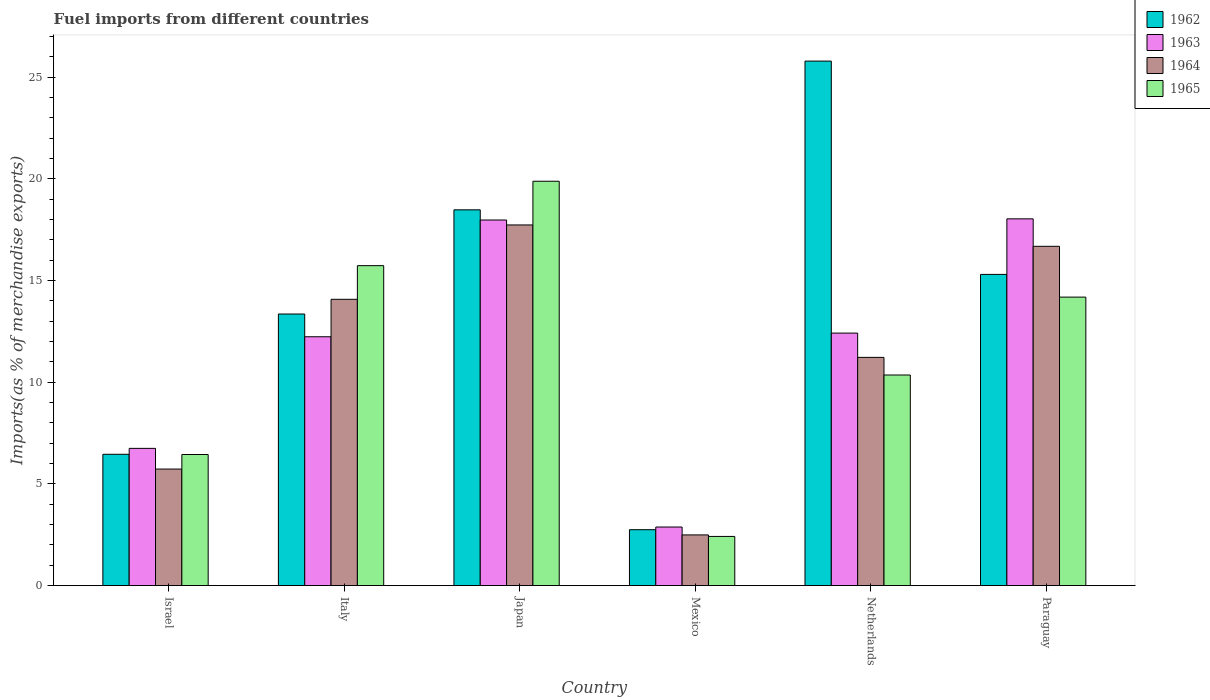Are the number of bars per tick equal to the number of legend labels?
Your answer should be very brief. Yes. Are the number of bars on each tick of the X-axis equal?
Keep it short and to the point. Yes. How many bars are there on the 2nd tick from the left?
Ensure brevity in your answer.  4. What is the label of the 5th group of bars from the left?
Your answer should be very brief. Netherlands. What is the percentage of imports to different countries in 1965 in Israel?
Provide a succinct answer. 6.44. Across all countries, what is the maximum percentage of imports to different countries in 1965?
Give a very brief answer. 19.88. Across all countries, what is the minimum percentage of imports to different countries in 1965?
Offer a very short reply. 2.42. What is the total percentage of imports to different countries in 1965 in the graph?
Your answer should be very brief. 69. What is the difference between the percentage of imports to different countries in 1962 in Israel and that in Japan?
Keep it short and to the point. -12.02. What is the difference between the percentage of imports to different countries in 1965 in Japan and the percentage of imports to different countries in 1964 in Mexico?
Ensure brevity in your answer.  17.39. What is the average percentage of imports to different countries in 1962 per country?
Give a very brief answer. 13.69. What is the difference between the percentage of imports to different countries of/in 1962 and percentage of imports to different countries of/in 1964 in Israel?
Keep it short and to the point. 0.73. In how many countries, is the percentage of imports to different countries in 1962 greater than 18 %?
Provide a short and direct response. 2. What is the ratio of the percentage of imports to different countries in 1964 in Italy to that in Netherlands?
Provide a short and direct response. 1.25. What is the difference between the highest and the second highest percentage of imports to different countries in 1965?
Your response must be concise. 5.7. What is the difference between the highest and the lowest percentage of imports to different countries in 1963?
Offer a very short reply. 15.15. In how many countries, is the percentage of imports to different countries in 1962 greater than the average percentage of imports to different countries in 1962 taken over all countries?
Keep it short and to the point. 3. Is it the case that in every country, the sum of the percentage of imports to different countries in 1963 and percentage of imports to different countries in 1964 is greater than the sum of percentage of imports to different countries in 1965 and percentage of imports to different countries in 1962?
Give a very brief answer. No. What does the 2nd bar from the left in Mexico represents?
Provide a succinct answer. 1963. What does the 2nd bar from the right in Japan represents?
Keep it short and to the point. 1964. Is it the case that in every country, the sum of the percentage of imports to different countries in 1963 and percentage of imports to different countries in 1965 is greater than the percentage of imports to different countries in 1964?
Your answer should be very brief. Yes. How many bars are there?
Your answer should be very brief. 24. How many countries are there in the graph?
Ensure brevity in your answer.  6. Does the graph contain any zero values?
Your answer should be compact. No. Does the graph contain grids?
Provide a succinct answer. No. Where does the legend appear in the graph?
Your answer should be compact. Top right. How are the legend labels stacked?
Provide a succinct answer. Vertical. What is the title of the graph?
Make the answer very short. Fuel imports from different countries. Does "1999" appear as one of the legend labels in the graph?
Give a very brief answer. No. What is the label or title of the X-axis?
Your answer should be compact. Country. What is the label or title of the Y-axis?
Offer a very short reply. Imports(as % of merchandise exports). What is the Imports(as % of merchandise exports) in 1962 in Israel?
Offer a terse response. 6.45. What is the Imports(as % of merchandise exports) in 1963 in Israel?
Your response must be concise. 6.75. What is the Imports(as % of merchandise exports) of 1964 in Israel?
Give a very brief answer. 5.73. What is the Imports(as % of merchandise exports) of 1965 in Israel?
Give a very brief answer. 6.44. What is the Imports(as % of merchandise exports) in 1962 in Italy?
Your answer should be very brief. 13.35. What is the Imports(as % of merchandise exports) in 1963 in Italy?
Your answer should be very brief. 12.23. What is the Imports(as % of merchandise exports) of 1964 in Italy?
Your answer should be very brief. 14.07. What is the Imports(as % of merchandise exports) in 1965 in Italy?
Make the answer very short. 15.73. What is the Imports(as % of merchandise exports) in 1962 in Japan?
Your answer should be very brief. 18.47. What is the Imports(as % of merchandise exports) of 1963 in Japan?
Provide a short and direct response. 17.97. What is the Imports(as % of merchandise exports) in 1964 in Japan?
Ensure brevity in your answer.  17.73. What is the Imports(as % of merchandise exports) of 1965 in Japan?
Offer a terse response. 19.88. What is the Imports(as % of merchandise exports) of 1962 in Mexico?
Make the answer very short. 2.75. What is the Imports(as % of merchandise exports) in 1963 in Mexico?
Provide a short and direct response. 2.88. What is the Imports(as % of merchandise exports) of 1964 in Mexico?
Make the answer very short. 2.49. What is the Imports(as % of merchandise exports) of 1965 in Mexico?
Ensure brevity in your answer.  2.42. What is the Imports(as % of merchandise exports) in 1962 in Netherlands?
Offer a very short reply. 25.79. What is the Imports(as % of merchandise exports) in 1963 in Netherlands?
Keep it short and to the point. 12.41. What is the Imports(as % of merchandise exports) of 1964 in Netherlands?
Offer a terse response. 11.22. What is the Imports(as % of merchandise exports) in 1965 in Netherlands?
Make the answer very short. 10.35. What is the Imports(as % of merchandise exports) of 1962 in Paraguay?
Provide a short and direct response. 15.3. What is the Imports(as % of merchandise exports) of 1963 in Paraguay?
Offer a terse response. 18.03. What is the Imports(as % of merchandise exports) of 1964 in Paraguay?
Keep it short and to the point. 16.68. What is the Imports(as % of merchandise exports) in 1965 in Paraguay?
Provide a short and direct response. 14.18. Across all countries, what is the maximum Imports(as % of merchandise exports) in 1962?
Ensure brevity in your answer.  25.79. Across all countries, what is the maximum Imports(as % of merchandise exports) in 1963?
Keep it short and to the point. 18.03. Across all countries, what is the maximum Imports(as % of merchandise exports) in 1964?
Provide a succinct answer. 17.73. Across all countries, what is the maximum Imports(as % of merchandise exports) in 1965?
Make the answer very short. 19.88. Across all countries, what is the minimum Imports(as % of merchandise exports) in 1962?
Offer a very short reply. 2.75. Across all countries, what is the minimum Imports(as % of merchandise exports) of 1963?
Provide a succinct answer. 2.88. Across all countries, what is the minimum Imports(as % of merchandise exports) in 1964?
Provide a succinct answer. 2.49. Across all countries, what is the minimum Imports(as % of merchandise exports) in 1965?
Your response must be concise. 2.42. What is the total Imports(as % of merchandise exports) in 1962 in the graph?
Your answer should be compact. 82.11. What is the total Imports(as % of merchandise exports) in 1963 in the graph?
Your response must be concise. 70.28. What is the total Imports(as % of merchandise exports) of 1964 in the graph?
Give a very brief answer. 67.93. What is the total Imports(as % of merchandise exports) of 1965 in the graph?
Offer a terse response. 69. What is the difference between the Imports(as % of merchandise exports) in 1962 in Israel and that in Italy?
Offer a terse response. -6.9. What is the difference between the Imports(as % of merchandise exports) of 1963 in Israel and that in Italy?
Provide a short and direct response. -5.49. What is the difference between the Imports(as % of merchandise exports) of 1964 in Israel and that in Italy?
Offer a very short reply. -8.35. What is the difference between the Imports(as % of merchandise exports) of 1965 in Israel and that in Italy?
Your answer should be very brief. -9.29. What is the difference between the Imports(as % of merchandise exports) of 1962 in Israel and that in Japan?
Make the answer very short. -12.02. What is the difference between the Imports(as % of merchandise exports) of 1963 in Israel and that in Japan?
Ensure brevity in your answer.  -11.23. What is the difference between the Imports(as % of merchandise exports) of 1964 in Israel and that in Japan?
Provide a succinct answer. -12. What is the difference between the Imports(as % of merchandise exports) in 1965 in Israel and that in Japan?
Your response must be concise. -13.44. What is the difference between the Imports(as % of merchandise exports) in 1962 in Israel and that in Mexico?
Your answer should be very brief. 3.71. What is the difference between the Imports(as % of merchandise exports) of 1963 in Israel and that in Mexico?
Ensure brevity in your answer.  3.87. What is the difference between the Imports(as % of merchandise exports) of 1964 in Israel and that in Mexico?
Offer a terse response. 3.24. What is the difference between the Imports(as % of merchandise exports) of 1965 in Israel and that in Mexico?
Provide a short and direct response. 4.03. What is the difference between the Imports(as % of merchandise exports) of 1962 in Israel and that in Netherlands?
Offer a very short reply. -19.33. What is the difference between the Imports(as % of merchandise exports) in 1963 in Israel and that in Netherlands?
Keep it short and to the point. -5.67. What is the difference between the Imports(as % of merchandise exports) of 1964 in Israel and that in Netherlands?
Your answer should be very brief. -5.49. What is the difference between the Imports(as % of merchandise exports) of 1965 in Israel and that in Netherlands?
Your answer should be very brief. -3.91. What is the difference between the Imports(as % of merchandise exports) in 1962 in Israel and that in Paraguay?
Your answer should be very brief. -8.85. What is the difference between the Imports(as % of merchandise exports) of 1963 in Israel and that in Paraguay?
Keep it short and to the point. -11.28. What is the difference between the Imports(as % of merchandise exports) of 1964 in Israel and that in Paraguay?
Ensure brevity in your answer.  -10.95. What is the difference between the Imports(as % of merchandise exports) in 1965 in Israel and that in Paraguay?
Ensure brevity in your answer.  -7.74. What is the difference between the Imports(as % of merchandise exports) of 1962 in Italy and that in Japan?
Offer a terse response. -5.12. What is the difference between the Imports(as % of merchandise exports) in 1963 in Italy and that in Japan?
Provide a succinct answer. -5.74. What is the difference between the Imports(as % of merchandise exports) in 1964 in Italy and that in Japan?
Offer a terse response. -3.66. What is the difference between the Imports(as % of merchandise exports) of 1965 in Italy and that in Japan?
Offer a terse response. -4.15. What is the difference between the Imports(as % of merchandise exports) in 1962 in Italy and that in Mexico?
Provide a short and direct response. 10.61. What is the difference between the Imports(as % of merchandise exports) of 1963 in Italy and that in Mexico?
Make the answer very short. 9.36. What is the difference between the Imports(as % of merchandise exports) in 1964 in Italy and that in Mexico?
Provide a short and direct response. 11.58. What is the difference between the Imports(as % of merchandise exports) in 1965 in Italy and that in Mexico?
Your answer should be very brief. 13.31. What is the difference between the Imports(as % of merchandise exports) in 1962 in Italy and that in Netherlands?
Give a very brief answer. -12.44. What is the difference between the Imports(as % of merchandise exports) of 1963 in Italy and that in Netherlands?
Ensure brevity in your answer.  -0.18. What is the difference between the Imports(as % of merchandise exports) in 1964 in Italy and that in Netherlands?
Your answer should be compact. 2.86. What is the difference between the Imports(as % of merchandise exports) of 1965 in Italy and that in Netherlands?
Make the answer very short. 5.38. What is the difference between the Imports(as % of merchandise exports) of 1962 in Italy and that in Paraguay?
Provide a short and direct response. -1.95. What is the difference between the Imports(as % of merchandise exports) in 1963 in Italy and that in Paraguay?
Provide a short and direct response. -5.8. What is the difference between the Imports(as % of merchandise exports) of 1964 in Italy and that in Paraguay?
Provide a short and direct response. -2.61. What is the difference between the Imports(as % of merchandise exports) in 1965 in Italy and that in Paraguay?
Make the answer very short. 1.55. What is the difference between the Imports(as % of merchandise exports) in 1962 in Japan and that in Mexico?
Provide a succinct answer. 15.73. What is the difference between the Imports(as % of merchandise exports) of 1963 in Japan and that in Mexico?
Provide a succinct answer. 15.1. What is the difference between the Imports(as % of merchandise exports) in 1964 in Japan and that in Mexico?
Your answer should be compact. 15.24. What is the difference between the Imports(as % of merchandise exports) of 1965 in Japan and that in Mexico?
Provide a succinct answer. 17.46. What is the difference between the Imports(as % of merchandise exports) of 1962 in Japan and that in Netherlands?
Provide a short and direct response. -7.31. What is the difference between the Imports(as % of merchandise exports) of 1963 in Japan and that in Netherlands?
Make the answer very short. 5.56. What is the difference between the Imports(as % of merchandise exports) in 1964 in Japan and that in Netherlands?
Your answer should be compact. 6.51. What is the difference between the Imports(as % of merchandise exports) in 1965 in Japan and that in Netherlands?
Keep it short and to the point. 9.53. What is the difference between the Imports(as % of merchandise exports) of 1962 in Japan and that in Paraguay?
Your response must be concise. 3.17. What is the difference between the Imports(as % of merchandise exports) of 1963 in Japan and that in Paraguay?
Offer a very short reply. -0.06. What is the difference between the Imports(as % of merchandise exports) of 1964 in Japan and that in Paraguay?
Offer a very short reply. 1.05. What is the difference between the Imports(as % of merchandise exports) in 1965 in Japan and that in Paraguay?
Give a very brief answer. 5.7. What is the difference between the Imports(as % of merchandise exports) of 1962 in Mexico and that in Netherlands?
Your response must be concise. -23.04. What is the difference between the Imports(as % of merchandise exports) in 1963 in Mexico and that in Netherlands?
Keep it short and to the point. -9.53. What is the difference between the Imports(as % of merchandise exports) in 1964 in Mexico and that in Netherlands?
Ensure brevity in your answer.  -8.73. What is the difference between the Imports(as % of merchandise exports) in 1965 in Mexico and that in Netherlands?
Provide a succinct answer. -7.94. What is the difference between the Imports(as % of merchandise exports) of 1962 in Mexico and that in Paraguay?
Your response must be concise. -12.55. What is the difference between the Imports(as % of merchandise exports) of 1963 in Mexico and that in Paraguay?
Your answer should be compact. -15.15. What is the difference between the Imports(as % of merchandise exports) of 1964 in Mexico and that in Paraguay?
Keep it short and to the point. -14.19. What is the difference between the Imports(as % of merchandise exports) in 1965 in Mexico and that in Paraguay?
Your answer should be very brief. -11.77. What is the difference between the Imports(as % of merchandise exports) of 1962 in Netherlands and that in Paraguay?
Keep it short and to the point. 10.49. What is the difference between the Imports(as % of merchandise exports) in 1963 in Netherlands and that in Paraguay?
Your answer should be very brief. -5.62. What is the difference between the Imports(as % of merchandise exports) of 1964 in Netherlands and that in Paraguay?
Provide a short and direct response. -5.46. What is the difference between the Imports(as % of merchandise exports) of 1965 in Netherlands and that in Paraguay?
Provide a succinct answer. -3.83. What is the difference between the Imports(as % of merchandise exports) of 1962 in Israel and the Imports(as % of merchandise exports) of 1963 in Italy?
Ensure brevity in your answer.  -5.78. What is the difference between the Imports(as % of merchandise exports) of 1962 in Israel and the Imports(as % of merchandise exports) of 1964 in Italy?
Offer a very short reply. -7.62. What is the difference between the Imports(as % of merchandise exports) of 1962 in Israel and the Imports(as % of merchandise exports) of 1965 in Italy?
Give a very brief answer. -9.28. What is the difference between the Imports(as % of merchandise exports) of 1963 in Israel and the Imports(as % of merchandise exports) of 1964 in Italy?
Provide a succinct answer. -7.33. What is the difference between the Imports(as % of merchandise exports) of 1963 in Israel and the Imports(as % of merchandise exports) of 1965 in Italy?
Provide a succinct answer. -8.98. What is the difference between the Imports(as % of merchandise exports) of 1964 in Israel and the Imports(as % of merchandise exports) of 1965 in Italy?
Offer a terse response. -10. What is the difference between the Imports(as % of merchandise exports) of 1962 in Israel and the Imports(as % of merchandise exports) of 1963 in Japan?
Make the answer very short. -11.52. What is the difference between the Imports(as % of merchandise exports) of 1962 in Israel and the Imports(as % of merchandise exports) of 1964 in Japan?
Make the answer very short. -11.28. What is the difference between the Imports(as % of merchandise exports) of 1962 in Israel and the Imports(as % of merchandise exports) of 1965 in Japan?
Offer a very short reply. -13.43. What is the difference between the Imports(as % of merchandise exports) of 1963 in Israel and the Imports(as % of merchandise exports) of 1964 in Japan?
Provide a short and direct response. -10.99. What is the difference between the Imports(as % of merchandise exports) in 1963 in Israel and the Imports(as % of merchandise exports) in 1965 in Japan?
Make the answer very short. -13.13. What is the difference between the Imports(as % of merchandise exports) in 1964 in Israel and the Imports(as % of merchandise exports) in 1965 in Japan?
Offer a very short reply. -14.15. What is the difference between the Imports(as % of merchandise exports) of 1962 in Israel and the Imports(as % of merchandise exports) of 1963 in Mexico?
Keep it short and to the point. 3.58. What is the difference between the Imports(as % of merchandise exports) in 1962 in Israel and the Imports(as % of merchandise exports) in 1964 in Mexico?
Your response must be concise. 3.96. What is the difference between the Imports(as % of merchandise exports) of 1962 in Israel and the Imports(as % of merchandise exports) of 1965 in Mexico?
Offer a terse response. 4.04. What is the difference between the Imports(as % of merchandise exports) of 1963 in Israel and the Imports(as % of merchandise exports) of 1964 in Mexico?
Offer a terse response. 4.26. What is the difference between the Imports(as % of merchandise exports) in 1963 in Israel and the Imports(as % of merchandise exports) in 1965 in Mexico?
Make the answer very short. 4.33. What is the difference between the Imports(as % of merchandise exports) of 1964 in Israel and the Imports(as % of merchandise exports) of 1965 in Mexico?
Your answer should be compact. 3.31. What is the difference between the Imports(as % of merchandise exports) in 1962 in Israel and the Imports(as % of merchandise exports) in 1963 in Netherlands?
Offer a terse response. -5.96. What is the difference between the Imports(as % of merchandise exports) of 1962 in Israel and the Imports(as % of merchandise exports) of 1964 in Netherlands?
Provide a succinct answer. -4.76. What is the difference between the Imports(as % of merchandise exports) in 1962 in Israel and the Imports(as % of merchandise exports) in 1965 in Netherlands?
Ensure brevity in your answer.  -3.9. What is the difference between the Imports(as % of merchandise exports) in 1963 in Israel and the Imports(as % of merchandise exports) in 1964 in Netherlands?
Offer a terse response. -4.47. What is the difference between the Imports(as % of merchandise exports) of 1963 in Israel and the Imports(as % of merchandise exports) of 1965 in Netherlands?
Offer a terse response. -3.61. What is the difference between the Imports(as % of merchandise exports) in 1964 in Israel and the Imports(as % of merchandise exports) in 1965 in Netherlands?
Ensure brevity in your answer.  -4.62. What is the difference between the Imports(as % of merchandise exports) of 1962 in Israel and the Imports(as % of merchandise exports) of 1963 in Paraguay?
Provide a succinct answer. -11.58. What is the difference between the Imports(as % of merchandise exports) of 1962 in Israel and the Imports(as % of merchandise exports) of 1964 in Paraguay?
Keep it short and to the point. -10.23. What is the difference between the Imports(as % of merchandise exports) of 1962 in Israel and the Imports(as % of merchandise exports) of 1965 in Paraguay?
Make the answer very short. -7.73. What is the difference between the Imports(as % of merchandise exports) in 1963 in Israel and the Imports(as % of merchandise exports) in 1964 in Paraguay?
Make the answer very short. -9.94. What is the difference between the Imports(as % of merchandise exports) in 1963 in Israel and the Imports(as % of merchandise exports) in 1965 in Paraguay?
Ensure brevity in your answer.  -7.44. What is the difference between the Imports(as % of merchandise exports) of 1964 in Israel and the Imports(as % of merchandise exports) of 1965 in Paraguay?
Ensure brevity in your answer.  -8.45. What is the difference between the Imports(as % of merchandise exports) of 1962 in Italy and the Imports(as % of merchandise exports) of 1963 in Japan?
Give a very brief answer. -4.62. What is the difference between the Imports(as % of merchandise exports) of 1962 in Italy and the Imports(as % of merchandise exports) of 1964 in Japan?
Make the answer very short. -4.38. What is the difference between the Imports(as % of merchandise exports) of 1962 in Italy and the Imports(as % of merchandise exports) of 1965 in Japan?
Keep it short and to the point. -6.53. What is the difference between the Imports(as % of merchandise exports) in 1963 in Italy and the Imports(as % of merchandise exports) in 1964 in Japan?
Offer a terse response. -5.5. What is the difference between the Imports(as % of merchandise exports) of 1963 in Italy and the Imports(as % of merchandise exports) of 1965 in Japan?
Provide a short and direct response. -7.65. What is the difference between the Imports(as % of merchandise exports) in 1964 in Italy and the Imports(as % of merchandise exports) in 1965 in Japan?
Offer a very short reply. -5.8. What is the difference between the Imports(as % of merchandise exports) in 1962 in Italy and the Imports(as % of merchandise exports) in 1963 in Mexico?
Give a very brief answer. 10.47. What is the difference between the Imports(as % of merchandise exports) in 1962 in Italy and the Imports(as % of merchandise exports) in 1964 in Mexico?
Give a very brief answer. 10.86. What is the difference between the Imports(as % of merchandise exports) of 1962 in Italy and the Imports(as % of merchandise exports) of 1965 in Mexico?
Provide a succinct answer. 10.94. What is the difference between the Imports(as % of merchandise exports) in 1963 in Italy and the Imports(as % of merchandise exports) in 1964 in Mexico?
Your response must be concise. 9.74. What is the difference between the Imports(as % of merchandise exports) of 1963 in Italy and the Imports(as % of merchandise exports) of 1965 in Mexico?
Offer a very short reply. 9.82. What is the difference between the Imports(as % of merchandise exports) of 1964 in Italy and the Imports(as % of merchandise exports) of 1965 in Mexico?
Offer a terse response. 11.66. What is the difference between the Imports(as % of merchandise exports) of 1962 in Italy and the Imports(as % of merchandise exports) of 1963 in Netherlands?
Give a very brief answer. 0.94. What is the difference between the Imports(as % of merchandise exports) in 1962 in Italy and the Imports(as % of merchandise exports) in 1964 in Netherlands?
Your answer should be compact. 2.13. What is the difference between the Imports(as % of merchandise exports) in 1962 in Italy and the Imports(as % of merchandise exports) in 1965 in Netherlands?
Make the answer very short. 3. What is the difference between the Imports(as % of merchandise exports) of 1963 in Italy and the Imports(as % of merchandise exports) of 1964 in Netherlands?
Offer a very short reply. 1.01. What is the difference between the Imports(as % of merchandise exports) of 1963 in Italy and the Imports(as % of merchandise exports) of 1965 in Netherlands?
Offer a very short reply. 1.88. What is the difference between the Imports(as % of merchandise exports) in 1964 in Italy and the Imports(as % of merchandise exports) in 1965 in Netherlands?
Your answer should be compact. 3.72. What is the difference between the Imports(as % of merchandise exports) of 1962 in Italy and the Imports(as % of merchandise exports) of 1963 in Paraguay?
Provide a succinct answer. -4.68. What is the difference between the Imports(as % of merchandise exports) of 1962 in Italy and the Imports(as % of merchandise exports) of 1964 in Paraguay?
Your response must be concise. -3.33. What is the difference between the Imports(as % of merchandise exports) of 1962 in Italy and the Imports(as % of merchandise exports) of 1965 in Paraguay?
Offer a very short reply. -0.83. What is the difference between the Imports(as % of merchandise exports) in 1963 in Italy and the Imports(as % of merchandise exports) in 1964 in Paraguay?
Keep it short and to the point. -4.45. What is the difference between the Imports(as % of merchandise exports) of 1963 in Italy and the Imports(as % of merchandise exports) of 1965 in Paraguay?
Ensure brevity in your answer.  -1.95. What is the difference between the Imports(as % of merchandise exports) in 1964 in Italy and the Imports(as % of merchandise exports) in 1965 in Paraguay?
Ensure brevity in your answer.  -0.11. What is the difference between the Imports(as % of merchandise exports) of 1962 in Japan and the Imports(as % of merchandise exports) of 1963 in Mexico?
Your answer should be compact. 15.6. What is the difference between the Imports(as % of merchandise exports) of 1962 in Japan and the Imports(as % of merchandise exports) of 1964 in Mexico?
Make the answer very short. 15.98. What is the difference between the Imports(as % of merchandise exports) in 1962 in Japan and the Imports(as % of merchandise exports) in 1965 in Mexico?
Make the answer very short. 16.06. What is the difference between the Imports(as % of merchandise exports) of 1963 in Japan and the Imports(as % of merchandise exports) of 1964 in Mexico?
Your answer should be compact. 15.48. What is the difference between the Imports(as % of merchandise exports) in 1963 in Japan and the Imports(as % of merchandise exports) in 1965 in Mexico?
Your answer should be very brief. 15.56. What is the difference between the Imports(as % of merchandise exports) in 1964 in Japan and the Imports(as % of merchandise exports) in 1965 in Mexico?
Keep it short and to the point. 15.32. What is the difference between the Imports(as % of merchandise exports) of 1962 in Japan and the Imports(as % of merchandise exports) of 1963 in Netherlands?
Offer a very short reply. 6.06. What is the difference between the Imports(as % of merchandise exports) in 1962 in Japan and the Imports(as % of merchandise exports) in 1964 in Netherlands?
Offer a terse response. 7.25. What is the difference between the Imports(as % of merchandise exports) in 1962 in Japan and the Imports(as % of merchandise exports) in 1965 in Netherlands?
Offer a very short reply. 8.12. What is the difference between the Imports(as % of merchandise exports) of 1963 in Japan and the Imports(as % of merchandise exports) of 1964 in Netherlands?
Offer a terse response. 6.76. What is the difference between the Imports(as % of merchandise exports) of 1963 in Japan and the Imports(as % of merchandise exports) of 1965 in Netherlands?
Keep it short and to the point. 7.62. What is the difference between the Imports(as % of merchandise exports) of 1964 in Japan and the Imports(as % of merchandise exports) of 1965 in Netherlands?
Keep it short and to the point. 7.38. What is the difference between the Imports(as % of merchandise exports) in 1962 in Japan and the Imports(as % of merchandise exports) in 1963 in Paraguay?
Offer a terse response. 0.44. What is the difference between the Imports(as % of merchandise exports) in 1962 in Japan and the Imports(as % of merchandise exports) in 1964 in Paraguay?
Provide a short and direct response. 1.79. What is the difference between the Imports(as % of merchandise exports) of 1962 in Japan and the Imports(as % of merchandise exports) of 1965 in Paraguay?
Ensure brevity in your answer.  4.29. What is the difference between the Imports(as % of merchandise exports) of 1963 in Japan and the Imports(as % of merchandise exports) of 1964 in Paraguay?
Keep it short and to the point. 1.29. What is the difference between the Imports(as % of merchandise exports) in 1963 in Japan and the Imports(as % of merchandise exports) in 1965 in Paraguay?
Your response must be concise. 3.79. What is the difference between the Imports(as % of merchandise exports) of 1964 in Japan and the Imports(as % of merchandise exports) of 1965 in Paraguay?
Ensure brevity in your answer.  3.55. What is the difference between the Imports(as % of merchandise exports) in 1962 in Mexico and the Imports(as % of merchandise exports) in 1963 in Netherlands?
Keep it short and to the point. -9.67. What is the difference between the Imports(as % of merchandise exports) in 1962 in Mexico and the Imports(as % of merchandise exports) in 1964 in Netherlands?
Provide a short and direct response. -8.47. What is the difference between the Imports(as % of merchandise exports) of 1962 in Mexico and the Imports(as % of merchandise exports) of 1965 in Netherlands?
Your response must be concise. -7.61. What is the difference between the Imports(as % of merchandise exports) in 1963 in Mexico and the Imports(as % of merchandise exports) in 1964 in Netherlands?
Offer a very short reply. -8.34. What is the difference between the Imports(as % of merchandise exports) in 1963 in Mexico and the Imports(as % of merchandise exports) in 1965 in Netherlands?
Provide a succinct answer. -7.47. What is the difference between the Imports(as % of merchandise exports) in 1964 in Mexico and the Imports(as % of merchandise exports) in 1965 in Netherlands?
Make the answer very short. -7.86. What is the difference between the Imports(as % of merchandise exports) in 1962 in Mexico and the Imports(as % of merchandise exports) in 1963 in Paraguay?
Provide a short and direct response. -15.28. What is the difference between the Imports(as % of merchandise exports) of 1962 in Mexico and the Imports(as % of merchandise exports) of 1964 in Paraguay?
Make the answer very short. -13.93. What is the difference between the Imports(as % of merchandise exports) in 1962 in Mexico and the Imports(as % of merchandise exports) in 1965 in Paraguay?
Provide a succinct answer. -11.44. What is the difference between the Imports(as % of merchandise exports) in 1963 in Mexico and the Imports(as % of merchandise exports) in 1964 in Paraguay?
Your answer should be very brief. -13.8. What is the difference between the Imports(as % of merchandise exports) in 1963 in Mexico and the Imports(as % of merchandise exports) in 1965 in Paraguay?
Give a very brief answer. -11.3. What is the difference between the Imports(as % of merchandise exports) in 1964 in Mexico and the Imports(as % of merchandise exports) in 1965 in Paraguay?
Ensure brevity in your answer.  -11.69. What is the difference between the Imports(as % of merchandise exports) of 1962 in Netherlands and the Imports(as % of merchandise exports) of 1963 in Paraguay?
Your response must be concise. 7.76. What is the difference between the Imports(as % of merchandise exports) of 1962 in Netherlands and the Imports(as % of merchandise exports) of 1964 in Paraguay?
Your response must be concise. 9.11. What is the difference between the Imports(as % of merchandise exports) in 1962 in Netherlands and the Imports(as % of merchandise exports) in 1965 in Paraguay?
Offer a terse response. 11.6. What is the difference between the Imports(as % of merchandise exports) in 1963 in Netherlands and the Imports(as % of merchandise exports) in 1964 in Paraguay?
Make the answer very short. -4.27. What is the difference between the Imports(as % of merchandise exports) of 1963 in Netherlands and the Imports(as % of merchandise exports) of 1965 in Paraguay?
Give a very brief answer. -1.77. What is the difference between the Imports(as % of merchandise exports) in 1964 in Netherlands and the Imports(as % of merchandise exports) in 1965 in Paraguay?
Keep it short and to the point. -2.96. What is the average Imports(as % of merchandise exports) of 1962 per country?
Your response must be concise. 13.69. What is the average Imports(as % of merchandise exports) of 1963 per country?
Your response must be concise. 11.71. What is the average Imports(as % of merchandise exports) of 1964 per country?
Your answer should be compact. 11.32. What is the average Imports(as % of merchandise exports) of 1965 per country?
Keep it short and to the point. 11.5. What is the difference between the Imports(as % of merchandise exports) in 1962 and Imports(as % of merchandise exports) in 1963 in Israel?
Your answer should be very brief. -0.29. What is the difference between the Imports(as % of merchandise exports) of 1962 and Imports(as % of merchandise exports) of 1964 in Israel?
Offer a very short reply. 0.73. What is the difference between the Imports(as % of merchandise exports) in 1962 and Imports(as % of merchandise exports) in 1965 in Israel?
Your answer should be very brief. 0.01. What is the difference between the Imports(as % of merchandise exports) in 1963 and Imports(as % of merchandise exports) in 1964 in Israel?
Your answer should be compact. 1.02. What is the difference between the Imports(as % of merchandise exports) of 1963 and Imports(as % of merchandise exports) of 1965 in Israel?
Your response must be concise. 0.3. What is the difference between the Imports(as % of merchandise exports) of 1964 and Imports(as % of merchandise exports) of 1965 in Israel?
Ensure brevity in your answer.  -0.72. What is the difference between the Imports(as % of merchandise exports) in 1962 and Imports(as % of merchandise exports) in 1963 in Italy?
Provide a succinct answer. 1.12. What is the difference between the Imports(as % of merchandise exports) of 1962 and Imports(as % of merchandise exports) of 1964 in Italy?
Your answer should be very brief. -0.72. What is the difference between the Imports(as % of merchandise exports) in 1962 and Imports(as % of merchandise exports) in 1965 in Italy?
Offer a terse response. -2.38. What is the difference between the Imports(as % of merchandise exports) in 1963 and Imports(as % of merchandise exports) in 1964 in Italy?
Provide a succinct answer. -1.84. What is the difference between the Imports(as % of merchandise exports) in 1963 and Imports(as % of merchandise exports) in 1965 in Italy?
Make the answer very short. -3.5. What is the difference between the Imports(as % of merchandise exports) in 1964 and Imports(as % of merchandise exports) in 1965 in Italy?
Make the answer very short. -1.65. What is the difference between the Imports(as % of merchandise exports) in 1962 and Imports(as % of merchandise exports) in 1964 in Japan?
Your response must be concise. 0.74. What is the difference between the Imports(as % of merchandise exports) of 1962 and Imports(as % of merchandise exports) of 1965 in Japan?
Your response must be concise. -1.41. What is the difference between the Imports(as % of merchandise exports) of 1963 and Imports(as % of merchandise exports) of 1964 in Japan?
Ensure brevity in your answer.  0.24. What is the difference between the Imports(as % of merchandise exports) in 1963 and Imports(as % of merchandise exports) in 1965 in Japan?
Offer a very short reply. -1.91. What is the difference between the Imports(as % of merchandise exports) of 1964 and Imports(as % of merchandise exports) of 1965 in Japan?
Your answer should be very brief. -2.15. What is the difference between the Imports(as % of merchandise exports) in 1962 and Imports(as % of merchandise exports) in 1963 in Mexico?
Keep it short and to the point. -0.13. What is the difference between the Imports(as % of merchandise exports) in 1962 and Imports(as % of merchandise exports) in 1964 in Mexico?
Offer a terse response. 0.26. What is the difference between the Imports(as % of merchandise exports) of 1962 and Imports(as % of merchandise exports) of 1965 in Mexico?
Your response must be concise. 0.33. What is the difference between the Imports(as % of merchandise exports) in 1963 and Imports(as % of merchandise exports) in 1964 in Mexico?
Keep it short and to the point. 0.39. What is the difference between the Imports(as % of merchandise exports) in 1963 and Imports(as % of merchandise exports) in 1965 in Mexico?
Offer a very short reply. 0.46. What is the difference between the Imports(as % of merchandise exports) in 1964 and Imports(as % of merchandise exports) in 1965 in Mexico?
Your response must be concise. 0.07. What is the difference between the Imports(as % of merchandise exports) of 1962 and Imports(as % of merchandise exports) of 1963 in Netherlands?
Provide a succinct answer. 13.37. What is the difference between the Imports(as % of merchandise exports) of 1962 and Imports(as % of merchandise exports) of 1964 in Netherlands?
Give a very brief answer. 14.57. What is the difference between the Imports(as % of merchandise exports) in 1962 and Imports(as % of merchandise exports) in 1965 in Netherlands?
Offer a very short reply. 15.43. What is the difference between the Imports(as % of merchandise exports) of 1963 and Imports(as % of merchandise exports) of 1964 in Netherlands?
Offer a very short reply. 1.19. What is the difference between the Imports(as % of merchandise exports) in 1963 and Imports(as % of merchandise exports) in 1965 in Netherlands?
Your answer should be compact. 2.06. What is the difference between the Imports(as % of merchandise exports) in 1964 and Imports(as % of merchandise exports) in 1965 in Netherlands?
Offer a very short reply. 0.87. What is the difference between the Imports(as % of merchandise exports) in 1962 and Imports(as % of merchandise exports) in 1963 in Paraguay?
Make the answer very short. -2.73. What is the difference between the Imports(as % of merchandise exports) of 1962 and Imports(as % of merchandise exports) of 1964 in Paraguay?
Keep it short and to the point. -1.38. What is the difference between the Imports(as % of merchandise exports) in 1962 and Imports(as % of merchandise exports) in 1965 in Paraguay?
Make the answer very short. 1.12. What is the difference between the Imports(as % of merchandise exports) of 1963 and Imports(as % of merchandise exports) of 1964 in Paraguay?
Give a very brief answer. 1.35. What is the difference between the Imports(as % of merchandise exports) in 1963 and Imports(as % of merchandise exports) in 1965 in Paraguay?
Ensure brevity in your answer.  3.85. What is the difference between the Imports(as % of merchandise exports) of 1964 and Imports(as % of merchandise exports) of 1965 in Paraguay?
Give a very brief answer. 2.5. What is the ratio of the Imports(as % of merchandise exports) in 1962 in Israel to that in Italy?
Your answer should be compact. 0.48. What is the ratio of the Imports(as % of merchandise exports) in 1963 in Israel to that in Italy?
Make the answer very short. 0.55. What is the ratio of the Imports(as % of merchandise exports) of 1964 in Israel to that in Italy?
Offer a terse response. 0.41. What is the ratio of the Imports(as % of merchandise exports) of 1965 in Israel to that in Italy?
Offer a very short reply. 0.41. What is the ratio of the Imports(as % of merchandise exports) in 1962 in Israel to that in Japan?
Provide a succinct answer. 0.35. What is the ratio of the Imports(as % of merchandise exports) of 1963 in Israel to that in Japan?
Your response must be concise. 0.38. What is the ratio of the Imports(as % of merchandise exports) of 1964 in Israel to that in Japan?
Make the answer very short. 0.32. What is the ratio of the Imports(as % of merchandise exports) in 1965 in Israel to that in Japan?
Offer a terse response. 0.32. What is the ratio of the Imports(as % of merchandise exports) in 1962 in Israel to that in Mexico?
Your answer should be very brief. 2.35. What is the ratio of the Imports(as % of merchandise exports) of 1963 in Israel to that in Mexico?
Offer a terse response. 2.34. What is the ratio of the Imports(as % of merchandise exports) in 1964 in Israel to that in Mexico?
Your answer should be very brief. 2.3. What is the ratio of the Imports(as % of merchandise exports) in 1965 in Israel to that in Mexico?
Ensure brevity in your answer.  2.67. What is the ratio of the Imports(as % of merchandise exports) of 1962 in Israel to that in Netherlands?
Ensure brevity in your answer.  0.25. What is the ratio of the Imports(as % of merchandise exports) of 1963 in Israel to that in Netherlands?
Your answer should be very brief. 0.54. What is the ratio of the Imports(as % of merchandise exports) in 1964 in Israel to that in Netherlands?
Ensure brevity in your answer.  0.51. What is the ratio of the Imports(as % of merchandise exports) in 1965 in Israel to that in Netherlands?
Give a very brief answer. 0.62. What is the ratio of the Imports(as % of merchandise exports) of 1962 in Israel to that in Paraguay?
Ensure brevity in your answer.  0.42. What is the ratio of the Imports(as % of merchandise exports) in 1963 in Israel to that in Paraguay?
Keep it short and to the point. 0.37. What is the ratio of the Imports(as % of merchandise exports) of 1964 in Israel to that in Paraguay?
Provide a succinct answer. 0.34. What is the ratio of the Imports(as % of merchandise exports) in 1965 in Israel to that in Paraguay?
Provide a short and direct response. 0.45. What is the ratio of the Imports(as % of merchandise exports) in 1962 in Italy to that in Japan?
Offer a terse response. 0.72. What is the ratio of the Imports(as % of merchandise exports) of 1963 in Italy to that in Japan?
Provide a succinct answer. 0.68. What is the ratio of the Imports(as % of merchandise exports) of 1964 in Italy to that in Japan?
Offer a very short reply. 0.79. What is the ratio of the Imports(as % of merchandise exports) in 1965 in Italy to that in Japan?
Offer a terse response. 0.79. What is the ratio of the Imports(as % of merchandise exports) of 1962 in Italy to that in Mexico?
Offer a terse response. 4.86. What is the ratio of the Imports(as % of merchandise exports) of 1963 in Italy to that in Mexico?
Keep it short and to the point. 4.25. What is the ratio of the Imports(as % of merchandise exports) in 1964 in Italy to that in Mexico?
Provide a succinct answer. 5.65. What is the ratio of the Imports(as % of merchandise exports) of 1965 in Italy to that in Mexico?
Your answer should be very brief. 6.51. What is the ratio of the Imports(as % of merchandise exports) of 1962 in Italy to that in Netherlands?
Make the answer very short. 0.52. What is the ratio of the Imports(as % of merchandise exports) in 1963 in Italy to that in Netherlands?
Keep it short and to the point. 0.99. What is the ratio of the Imports(as % of merchandise exports) of 1964 in Italy to that in Netherlands?
Keep it short and to the point. 1.25. What is the ratio of the Imports(as % of merchandise exports) of 1965 in Italy to that in Netherlands?
Offer a very short reply. 1.52. What is the ratio of the Imports(as % of merchandise exports) of 1962 in Italy to that in Paraguay?
Give a very brief answer. 0.87. What is the ratio of the Imports(as % of merchandise exports) of 1963 in Italy to that in Paraguay?
Your response must be concise. 0.68. What is the ratio of the Imports(as % of merchandise exports) in 1964 in Italy to that in Paraguay?
Ensure brevity in your answer.  0.84. What is the ratio of the Imports(as % of merchandise exports) of 1965 in Italy to that in Paraguay?
Offer a very short reply. 1.11. What is the ratio of the Imports(as % of merchandise exports) of 1962 in Japan to that in Mexico?
Make the answer very short. 6.72. What is the ratio of the Imports(as % of merchandise exports) in 1963 in Japan to that in Mexico?
Your answer should be compact. 6.24. What is the ratio of the Imports(as % of merchandise exports) in 1964 in Japan to that in Mexico?
Provide a short and direct response. 7.12. What is the ratio of the Imports(as % of merchandise exports) in 1965 in Japan to that in Mexico?
Give a very brief answer. 8.23. What is the ratio of the Imports(as % of merchandise exports) in 1962 in Japan to that in Netherlands?
Provide a succinct answer. 0.72. What is the ratio of the Imports(as % of merchandise exports) in 1963 in Japan to that in Netherlands?
Ensure brevity in your answer.  1.45. What is the ratio of the Imports(as % of merchandise exports) in 1964 in Japan to that in Netherlands?
Your response must be concise. 1.58. What is the ratio of the Imports(as % of merchandise exports) of 1965 in Japan to that in Netherlands?
Your answer should be very brief. 1.92. What is the ratio of the Imports(as % of merchandise exports) of 1962 in Japan to that in Paraguay?
Ensure brevity in your answer.  1.21. What is the ratio of the Imports(as % of merchandise exports) of 1963 in Japan to that in Paraguay?
Provide a short and direct response. 1. What is the ratio of the Imports(as % of merchandise exports) in 1964 in Japan to that in Paraguay?
Offer a very short reply. 1.06. What is the ratio of the Imports(as % of merchandise exports) in 1965 in Japan to that in Paraguay?
Make the answer very short. 1.4. What is the ratio of the Imports(as % of merchandise exports) of 1962 in Mexico to that in Netherlands?
Make the answer very short. 0.11. What is the ratio of the Imports(as % of merchandise exports) of 1963 in Mexico to that in Netherlands?
Offer a terse response. 0.23. What is the ratio of the Imports(as % of merchandise exports) in 1964 in Mexico to that in Netherlands?
Provide a short and direct response. 0.22. What is the ratio of the Imports(as % of merchandise exports) of 1965 in Mexico to that in Netherlands?
Give a very brief answer. 0.23. What is the ratio of the Imports(as % of merchandise exports) in 1962 in Mexico to that in Paraguay?
Your response must be concise. 0.18. What is the ratio of the Imports(as % of merchandise exports) of 1963 in Mexico to that in Paraguay?
Your answer should be very brief. 0.16. What is the ratio of the Imports(as % of merchandise exports) in 1964 in Mexico to that in Paraguay?
Your answer should be very brief. 0.15. What is the ratio of the Imports(as % of merchandise exports) of 1965 in Mexico to that in Paraguay?
Provide a short and direct response. 0.17. What is the ratio of the Imports(as % of merchandise exports) of 1962 in Netherlands to that in Paraguay?
Your answer should be compact. 1.69. What is the ratio of the Imports(as % of merchandise exports) in 1963 in Netherlands to that in Paraguay?
Your response must be concise. 0.69. What is the ratio of the Imports(as % of merchandise exports) of 1964 in Netherlands to that in Paraguay?
Provide a succinct answer. 0.67. What is the ratio of the Imports(as % of merchandise exports) of 1965 in Netherlands to that in Paraguay?
Provide a succinct answer. 0.73. What is the difference between the highest and the second highest Imports(as % of merchandise exports) in 1962?
Give a very brief answer. 7.31. What is the difference between the highest and the second highest Imports(as % of merchandise exports) of 1963?
Make the answer very short. 0.06. What is the difference between the highest and the second highest Imports(as % of merchandise exports) of 1964?
Provide a short and direct response. 1.05. What is the difference between the highest and the second highest Imports(as % of merchandise exports) in 1965?
Ensure brevity in your answer.  4.15. What is the difference between the highest and the lowest Imports(as % of merchandise exports) in 1962?
Keep it short and to the point. 23.04. What is the difference between the highest and the lowest Imports(as % of merchandise exports) of 1963?
Ensure brevity in your answer.  15.15. What is the difference between the highest and the lowest Imports(as % of merchandise exports) in 1964?
Your answer should be very brief. 15.24. What is the difference between the highest and the lowest Imports(as % of merchandise exports) in 1965?
Give a very brief answer. 17.46. 